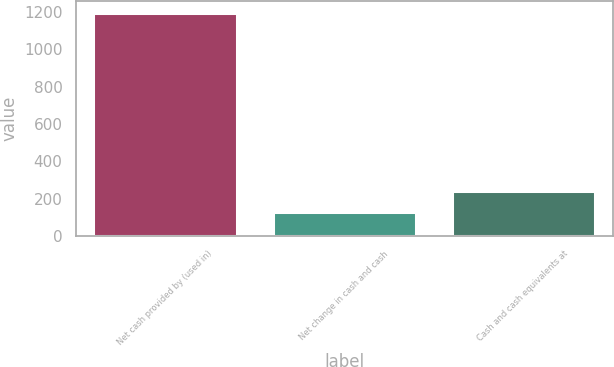Convert chart to OTSL. <chart><loc_0><loc_0><loc_500><loc_500><bar_chart><fcel>Net cash provided by (used in)<fcel>Net change in cash and cash<fcel>Cash and cash equivalents at<nl><fcel>1196.93<fcel>130.23<fcel>240.66<nl></chart> 